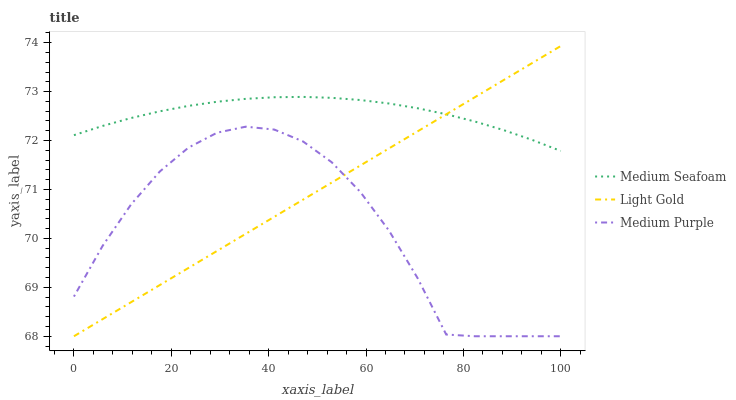Does Medium Purple have the minimum area under the curve?
Answer yes or no. Yes. Does Medium Seafoam have the maximum area under the curve?
Answer yes or no. Yes. Does Light Gold have the minimum area under the curve?
Answer yes or no. No. Does Light Gold have the maximum area under the curve?
Answer yes or no. No. Is Light Gold the smoothest?
Answer yes or no. Yes. Is Medium Purple the roughest?
Answer yes or no. Yes. Is Medium Seafoam the smoothest?
Answer yes or no. No. Is Medium Seafoam the roughest?
Answer yes or no. No. Does Medium Purple have the lowest value?
Answer yes or no. Yes. Does Medium Seafoam have the lowest value?
Answer yes or no. No. Does Light Gold have the highest value?
Answer yes or no. Yes. Does Medium Seafoam have the highest value?
Answer yes or no. No. Is Medium Purple less than Medium Seafoam?
Answer yes or no. Yes. Is Medium Seafoam greater than Medium Purple?
Answer yes or no. Yes. Does Medium Purple intersect Light Gold?
Answer yes or no. Yes. Is Medium Purple less than Light Gold?
Answer yes or no. No. Is Medium Purple greater than Light Gold?
Answer yes or no. No. Does Medium Purple intersect Medium Seafoam?
Answer yes or no. No. 